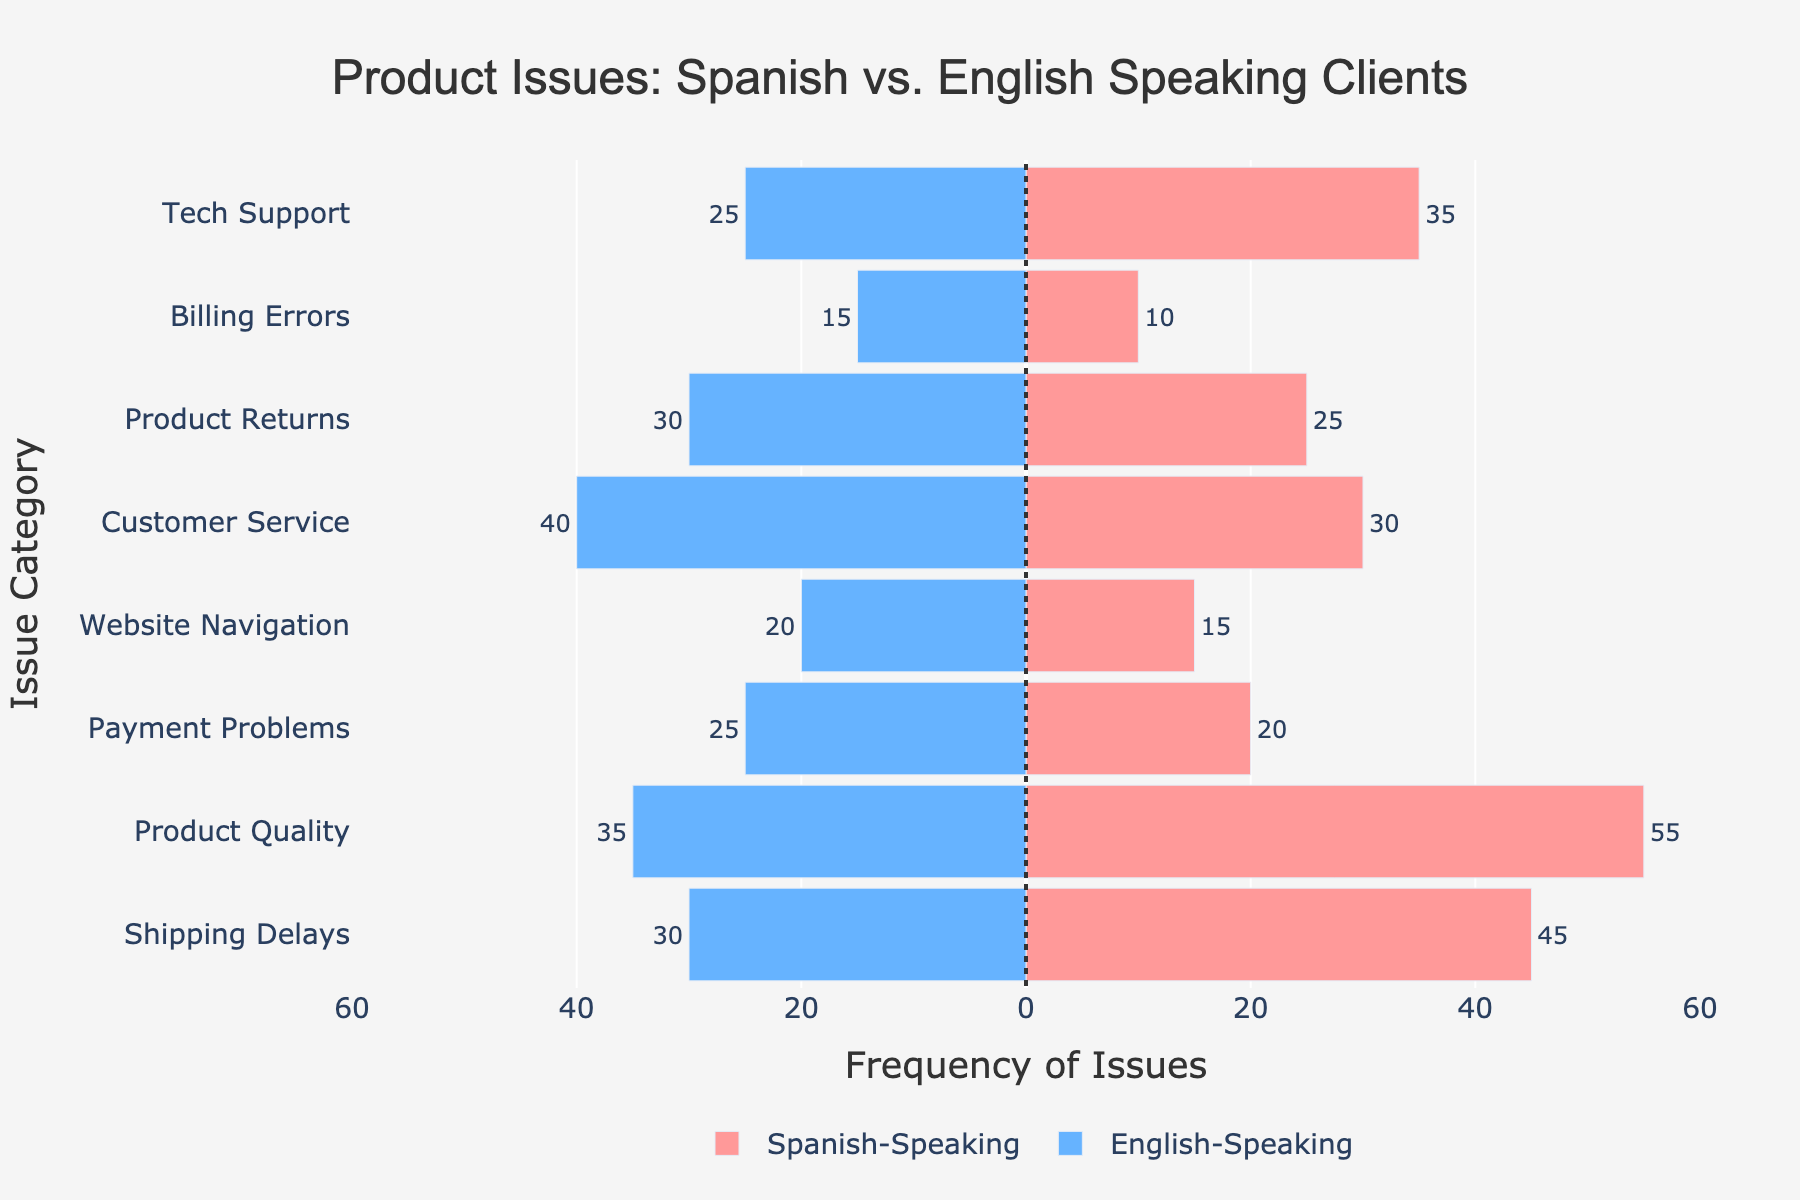What is the most frequently reported issue by Spanish-speaking clients? Identify the longest red bar on the chart which corresponds to Spanish-speaking clients. The "Product Quality" category has the longest bar with a value of 55.
Answer: Product Quality Which issue category shows the largest difference between Spanish and English-speaking clients? Calculate the absolute difference in the frequency of issues reported for each category and identify the largest difference. The largest difference is for "Product Quality" with a difference of 20 (55 - 35).
Answer: Product Quality How many more Spanish-speaking clients reported "Shipping Delays" compared to English-speaking clients? Look at the values for "Shipping Delays" in both groups. Spanish-speaking clients reported 45 while English-speaking clients reported 30. The difference is 45 - 30 = 15.
Answer: 15 For which issue category do more English-speaking clients report issues than Spanish-speaking clients? Identify any categories where the blue bar (English-speaking) extends further to the left than the red bar (Spanish-speaking). "Customer Service" and "Payment Problems" show more reports from English-speaking clients.
Answer: Customer Service, Payment Problems Are there any issue categories where the number of reports is equal between Spanish and English-speaking clients? Compare the length of the red and blue bars for each category to see if they are equal. None of the issue categories have equal reports.
Answer: None What's the average number of issues reported by Spanish-speaking clients for all categories? Sum the issue reports for Spanish-speaking clients across all categories and divide by the number of categories. The sum is 45 + 55 + 20 + 15 + 30 + 25 + 10 + 35 = 235. There are 8 categories. The average is 235 / 8 = 29.375.
Answer: 29.375 Which category shows the smallest number of issues reported by Spanish-speaking clients? Identify the shortest red bar on the chart. The "Billing Errors" category has the shortest bar with a value of 10.
Answer: Billing Errors In which issue category is the difference between the number of reports from Spanish and English-speaking clients closest to zero? Calculate the absolute difference between Spanish and English-speaking clients for all categories to find the smallest difference. The closest difference is for "Product Returns" with a difference of 5 (25 - 30).
Answer: Product Returns What is the total number of issues reported by both Spanish and English-speaking clients for "Tech Support"? Sum the values for Spanish-speaking and English-speaking clients in the "Tech Support" category. The total is 35 (Spanish-speaking) + 25 (English-speaking) = 60.
Answer: 60 Which color represents the reports from English-speaking clients? Observe the color of the bars representing English-speaking clients. The bars are colored blue.
Answer: Blue 